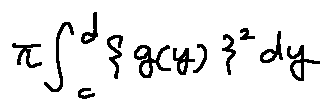Convert formula to latex. <formula><loc_0><loc_0><loc_500><loc_500>\pi \int \lim i t s _ { c } ^ { d } \{ g ( y ) \} ^ { 2 } d y</formula> 